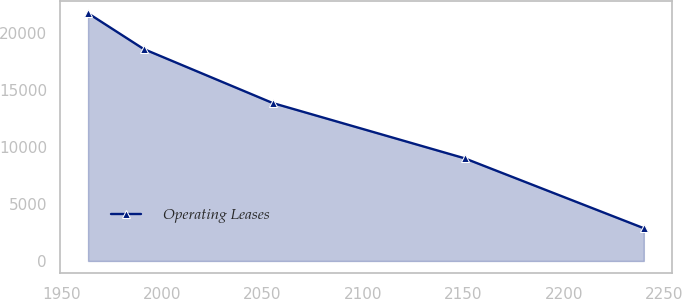Convert chart. <chart><loc_0><loc_0><loc_500><loc_500><line_chart><ecel><fcel>Operating Leases<nl><fcel>1963.33<fcel>21738.7<nl><fcel>1990.97<fcel>18601.1<nl><fcel>2055.17<fcel>13857.9<nl><fcel>2150.56<fcel>9011.09<nl><fcel>2239.71<fcel>2873.97<nl></chart> 